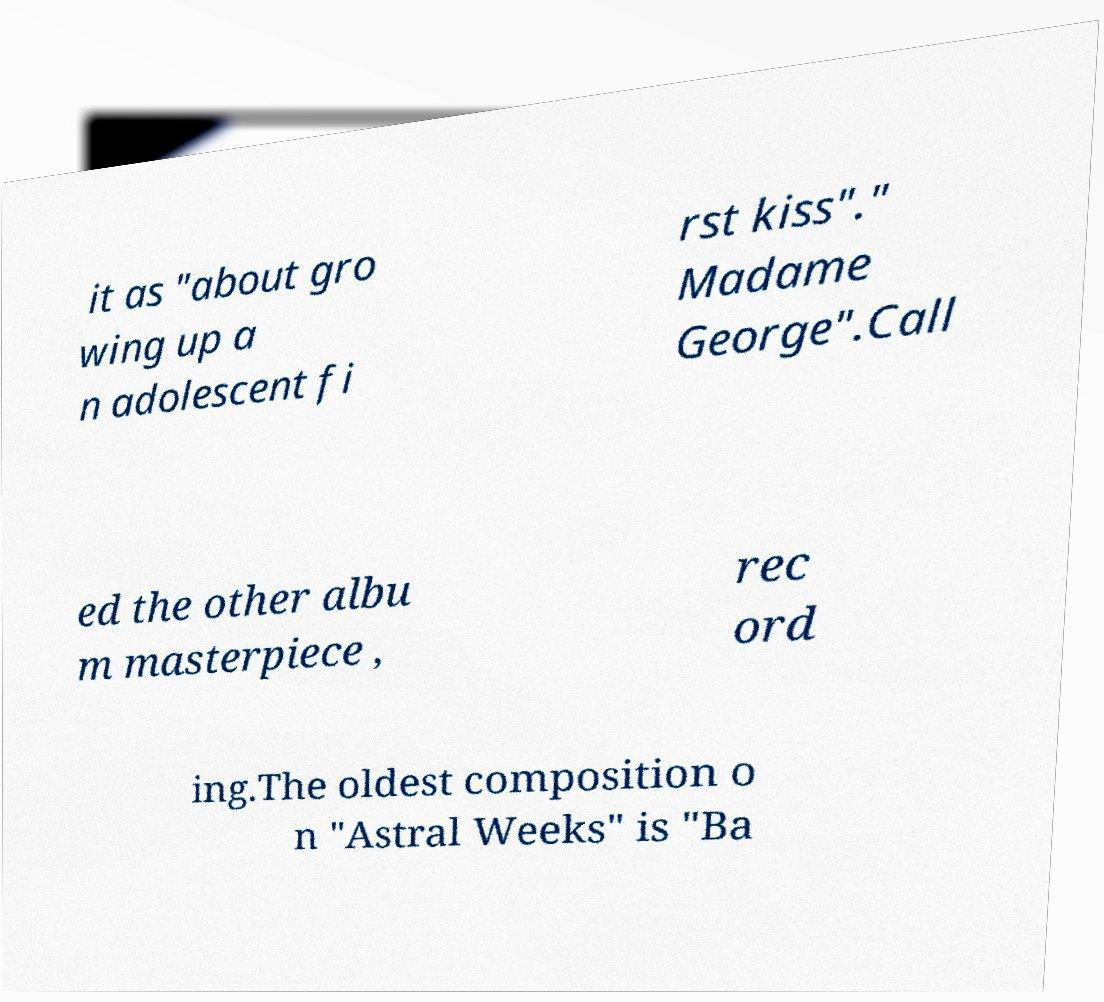There's text embedded in this image that I need extracted. Can you transcribe it verbatim? it as "about gro wing up a n adolescent fi rst kiss"." Madame George".Call ed the other albu m masterpiece , rec ord ing.The oldest composition o n "Astral Weeks" is "Ba 